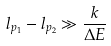<formula> <loc_0><loc_0><loc_500><loc_500>l _ { p _ { 1 } } - l _ { p _ { 2 } } \gg \frac { k } { \Delta E }</formula> 